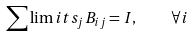Convert formula to latex. <formula><loc_0><loc_0><loc_500><loc_500>\sum \lim i t s _ { j } B _ { i j } = I , \quad \forall i</formula> 